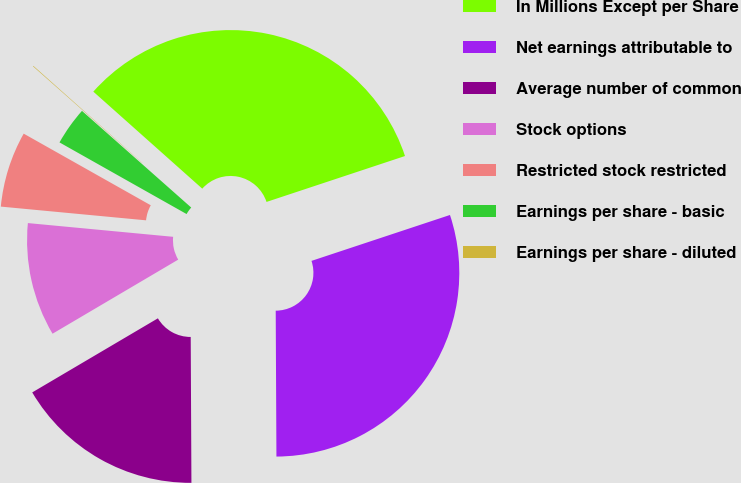<chart> <loc_0><loc_0><loc_500><loc_500><pie_chart><fcel>In Millions Except per Share<fcel>Net earnings attributable to<fcel>Average number of common<fcel>Stock options<fcel>Restricted stock restricted<fcel>Earnings per share - basic<fcel>Earnings per share - diluted<nl><fcel>33.33%<fcel>30.02%<fcel>16.6%<fcel>9.98%<fcel>6.67%<fcel>3.36%<fcel>0.05%<nl></chart> 